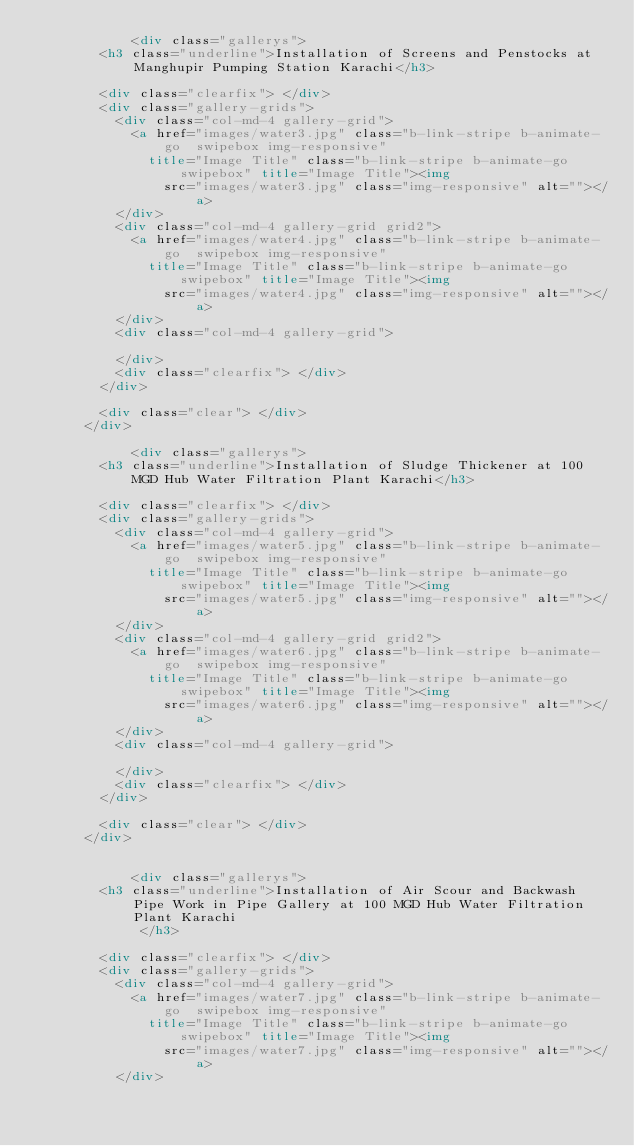<code> <loc_0><loc_0><loc_500><loc_500><_HTML_>            <div class="gallerys">
				<h3 class="underline">Installation of Screens and Penstocks at Manghupir Pumping Station Karachi</h3>
            
				<div class="clearfix"> </div>
				<div class="gallery-grids">
					<div class="col-md-4 gallery-grid">
						<a href="images/water3.jpg" class="b-link-stripe b-animate-go  swipebox img-responsive"
							title="Image Title" class="b-link-stripe b-animate-go  swipebox" title="Image Title"><img
								src="images/water3.jpg" class="img-responsive" alt=""></a>
					</div>
					<div class="col-md-4 gallery-grid grid2">
						<a href="images/water4.jpg" class="b-link-stripe b-animate-go  swipebox img-responsive"
							title="Image Title" class="b-link-stripe b-animate-go  swipebox" title="Image Title"><img
								src="images/water4.jpg" class="img-responsive" alt=""></a>
					</div>
					<div class="col-md-4 gallery-grid">
						
					</div>
					<div class="clearfix"> </div>
				</div>
                
				<div class="clear"> </div>
			</div>

            <div class="gallerys">
				<h3 class="underline">Installation of Sludge Thickener at 100 MGD Hub Water Filtration Plant Karachi</h3>
            
				<div class="clearfix"> </div>
				<div class="gallery-grids">
					<div class="col-md-4 gallery-grid">
						<a href="images/water5.jpg" class="b-link-stripe b-animate-go  swipebox img-responsive"
							title="Image Title" class="b-link-stripe b-animate-go  swipebox" title="Image Title"><img
								src="images/water5.jpg" class="img-responsive" alt=""></a>
					</div>
					<div class="col-md-4 gallery-grid grid2">
						<a href="images/water6.jpg" class="b-link-stripe b-animate-go  swipebox img-responsive"
							title="Image Title" class="b-link-stripe b-animate-go  swipebox" title="Image Title"><img
								src="images/water6.jpg" class="img-responsive" alt=""></a>
					</div>
					<div class="col-md-4 gallery-grid">
						
					</div>
					<div class="clearfix"> </div>
				</div>
                
				<div class="clear"> </div>
			</div>


            <div class="gallerys">
				<h3 class="underline">Installation of Air Scour and Backwash Pipe Work in Pipe Gallery at 100 MGD Hub Water Filtration Plant Karachi
             </h3>
            
				<div class="clearfix"> </div>
				<div class="gallery-grids">
					<div class="col-md-4 gallery-grid">
						<a href="images/water7.jpg" class="b-link-stripe b-animate-go  swipebox img-responsive"
							title="Image Title" class="b-link-stripe b-animate-go  swipebox" title="Image Title"><img
								src="images/water7.jpg" class="img-responsive" alt=""></a>
					</div></code> 